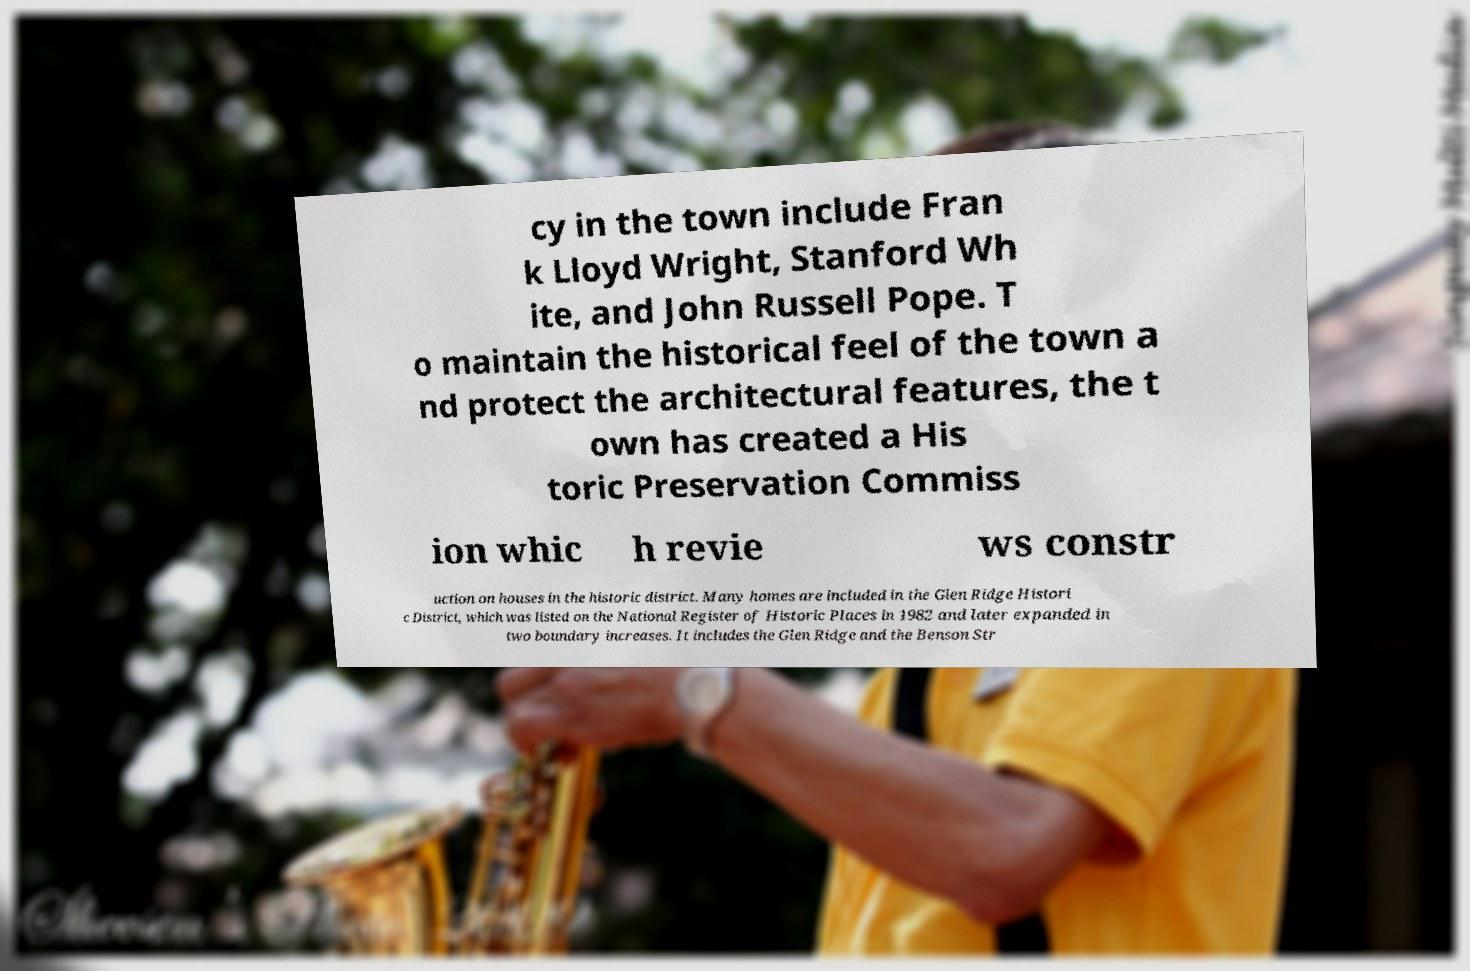Could you assist in decoding the text presented in this image and type it out clearly? cy in the town include Fran k Lloyd Wright, Stanford Wh ite, and John Russell Pope. T o maintain the historical feel of the town a nd protect the architectural features, the t own has created a His toric Preservation Commiss ion whic h revie ws constr uction on houses in the historic district. Many homes are included in the Glen Ridge Histori c District, which was listed on the National Register of Historic Places in 1982 and later expanded in two boundary increases. It includes the Glen Ridge and the Benson Str 